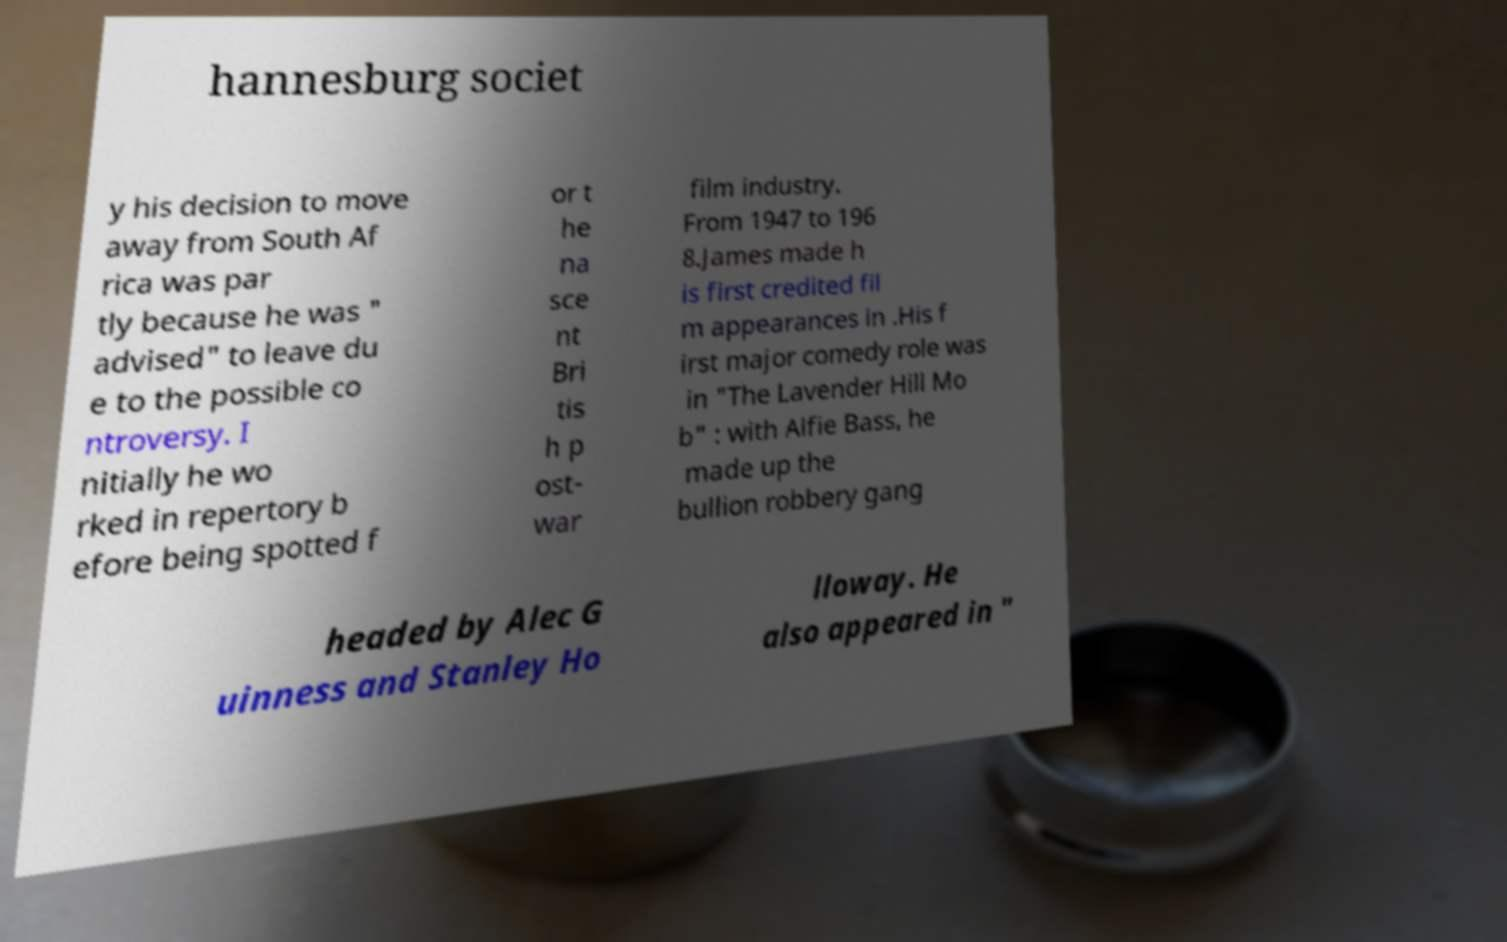Can you read and provide the text displayed in the image?This photo seems to have some interesting text. Can you extract and type it out for me? hannesburg societ y his decision to move away from South Af rica was par tly because he was " advised" to leave du e to the possible co ntroversy. I nitially he wo rked in repertory b efore being spotted f or t he na sce nt Bri tis h p ost- war film industry. From 1947 to 196 8.James made h is first credited fil m appearances in .His f irst major comedy role was in "The Lavender Hill Mo b" : with Alfie Bass, he made up the bullion robbery gang headed by Alec G uinness and Stanley Ho lloway. He also appeared in " 